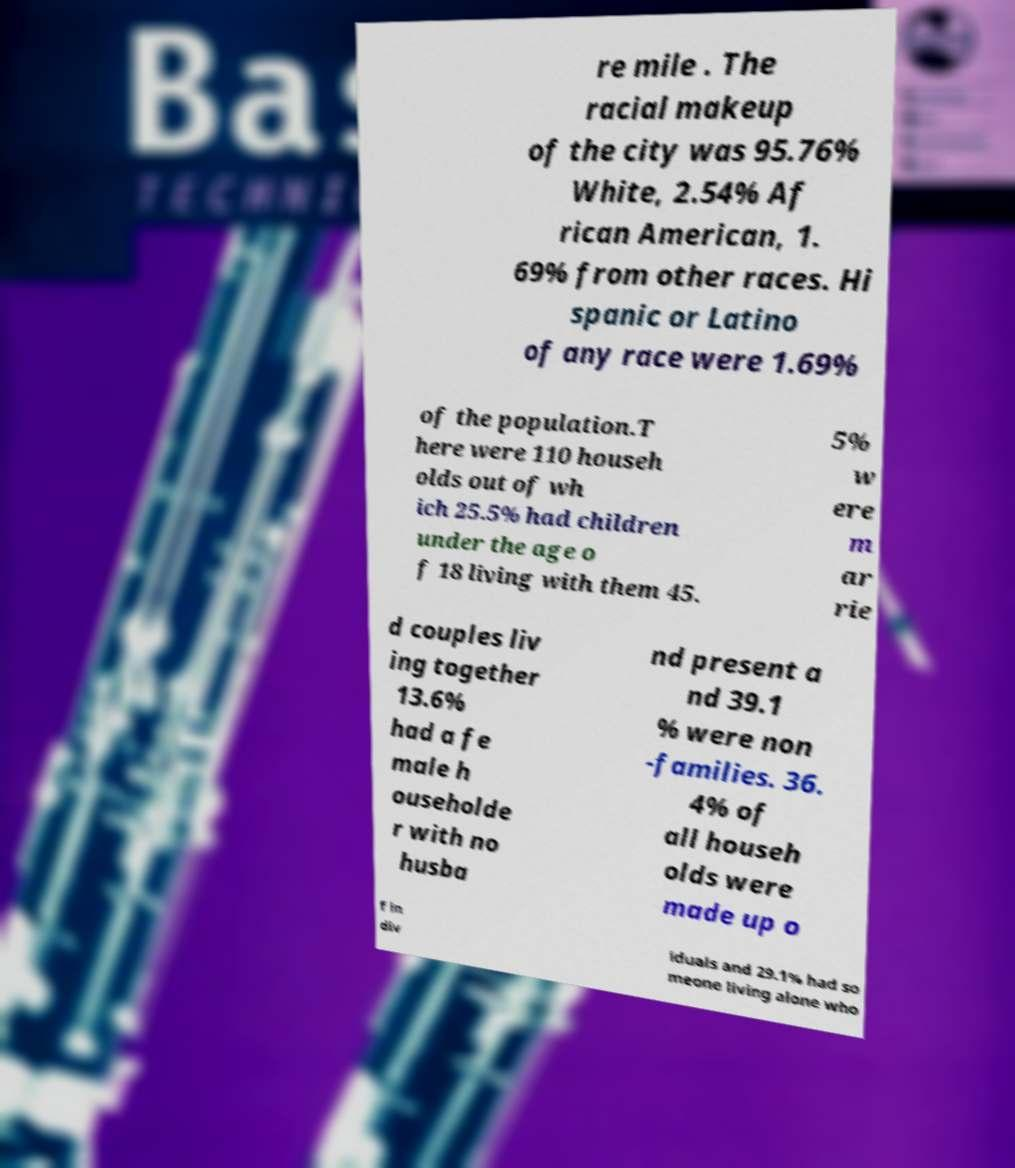Please identify and transcribe the text found in this image. re mile . The racial makeup of the city was 95.76% White, 2.54% Af rican American, 1. 69% from other races. Hi spanic or Latino of any race were 1.69% of the population.T here were 110 househ olds out of wh ich 25.5% had children under the age o f 18 living with them 45. 5% w ere m ar rie d couples liv ing together 13.6% had a fe male h ouseholde r with no husba nd present a nd 39.1 % were non -families. 36. 4% of all househ olds were made up o f in div iduals and 29.1% had so meone living alone who 